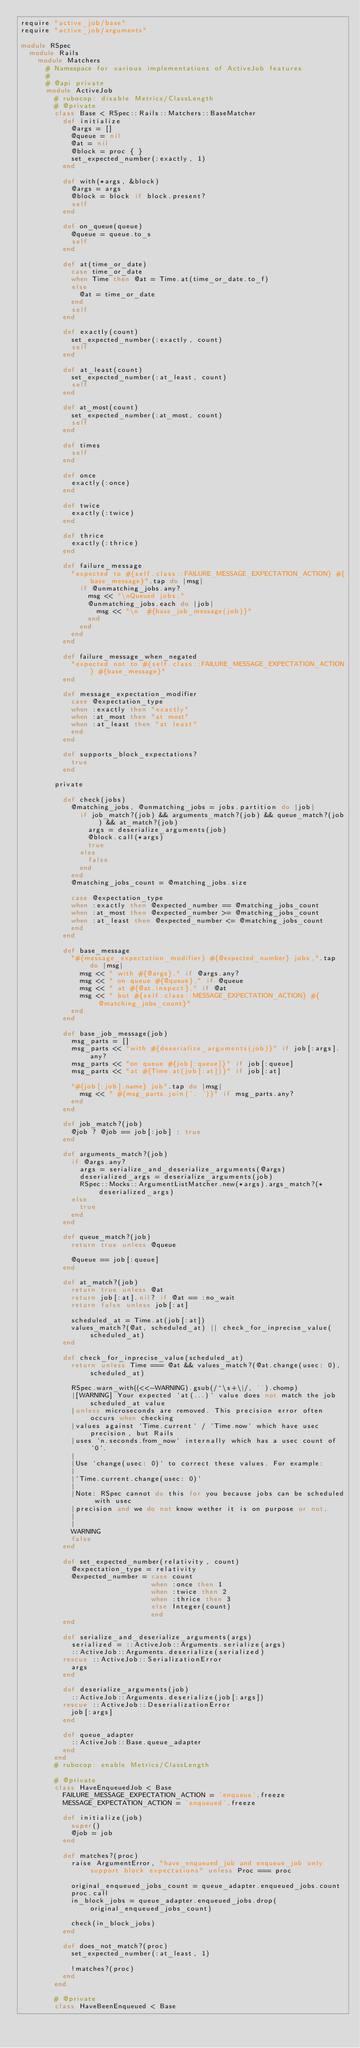Convert code to text. <code><loc_0><loc_0><loc_500><loc_500><_Ruby_>require "active_job/base"
require "active_job/arguments"

module RSpec
  module Rails
    module Matchers
      # Namespace for various implementations of ActiveJob features
      #
      # @api private
      module ActiveJob
        # rubocop: disable Metrics/ClassLength
        # @private
        class Base < RSpec::Rails::Matchers::BaseMatcher
          def initialize
            @args = []
            @queue = nil
            @at = nil
            @block = proc { }
            set_expected_number(:exactly, 1)
          end

          def with(*args, &block)
            @args = args
            @block = block if block.present?
            self
          end

          def on_queue(queue)
            @queue = queue.to_s
            self
          end

          def at(time_or_date)
            case time_or_date
            when Time then @at = Time.at(time_or_date.to_f)
            else
              @at = time_or_date
            end
            self
          end

          def exactly(count)
            set_expected_number(:exactly, count)
            self
          end

          def at_least(count)
            set_expected_number(:at_least, count)
            self
          end

          def at_most(count)
            set_expected_number(:at_most, count)
            self
          end

          def times
            self
          end

          def once
            exactly(:once)
          end

          def twice
            exactly(:twice)
          end

          def thrice
            exactly(:thrice)
          end

          def failure_message
            "expected to #{self.class::FAILURE_MESSAGE_EXPECTATION_ACTION} #{base_message}".tap do |msg|
              if @unmatching_jobs.any?
                msg << "\nQueued jobs:"
                @unmatching_jobs.each do |job|
                  msg << "\n  #{base_job_message(job)}"
                end
              end
            end
          end

          def failure_message_when_negated
            "expected not to #{self.class::FAILURE_MESSAGE_EXPECTATION_ACTION} #{base_message}"
          end

          def message_expectation_modifier
            case @expectation_type
            when :exactly then "exactly"
            when :at_most then "at most"
            when :at_least then "at least"
            end
          end

          def supports_block_expectations?
            true
          end

        private

          def check(jobs)
            @matching_jobs, @unmatching_jobs = jobs.partition do |job|
              if job_match?(job) && arguments_match?(job) && queue_match?(job) && at_match?(job)
                args = deserialize_arguments(job)
                @block.call(*args)
                true
              else
                false
              end
            end
            @matching_jobs_count = @matching_jobs.size

            case @expectation_type
            when :exactly then @expected_number == @matching_jobs_count
            when :at_most then @expected_number >= @matching_jobs_count
            when :at_least then @expected_number <= @matching_jobs_count
            end
          end

          def base_message
            "#{message_expectation_modifier} #{@expected_number} jobs,".tap do |msg|
              msg << " with #{@args}," if @args.any?
              msg << " on queue #{@queue}," if @queue
              msg << " at #{@at.inspect}," if @at
              msg << " but #{self.class::MESSAGE_EXPECTATION_ACTION} #{@matching_jobs_count}"
            end
          end

          def base_job_message(job)
            msg_parts = []
            msg_parts << "with #{deserialize_arguments(job)}" if job[:args].any?
            msg_parts << "on queue #{job[:queue]}" if job[:queue]
            msg_parts << "at #{Time.at(job[:at])}" if job[:at]

            "#{job[:job].name} job".tap do |msg|
              msg << " #{msg_parts.join(', ')}" if msg_parts.any?
            end
          end

          def job_match?(job)
            @job ? @job == job[:job] : true
          end

          def arguments_match?(job)
            if @args.any?
              args = serialize_and_deserialize_arguments(@args)
              deserialized_args = deserialize_arguments(job)
              RSpec::Mocks::ArgumentListMatcher.new(*args).args_match?(*deserialized_args)
            else
              true
            end
          end

          def queue_match?(job)
            return true unless @queue

            @queue == job[:queue]
          end

          def at_match?(job)
            return true unless @at
            return job[:at].nil? if @at == :no_wait
            return false unless job[:at]

            scheduled_at = Time.at(job[:at])
            values_match?(@at, scheduled_at) || check_for_inprecise_value(scheduled_at)
          end

          def check_for_inprecise_value(scheduled_at)
            return unless Time === @at && values_match?(@at.change(usec: 0), scheduled_at)

            RSpec.warn_with((<<-WARNING).gsub(/^\s+\|/, '').chomp)
            |[WARNING] Your expected `at(...)` value does not match the job scheduled_at value
            |unless microseconds are removed. This precision error often occurs when checking
            |values against `Time.current` / `Time.now` which have usec precision, but Rails
            |uses `n.seconds.from_now` internally which has a usec count of `0`.
            |
            |Use `change(usec: 0)` to correct these values. For example:
            |
            |`Time.current.change(usec: 0)`
            |
            |Note: RSpec cannot do this for you because jobs can be scheduled with usec
            |precision and we do not know wether it is on purpose or not.
            |
            |
            WARNING
            false
          end

          def set_expected_number(relativity, count)
            @expectation_type = relativity
            @expected_number = case count
                               when :once then 1
                               when :twice then 2
                               when :thrice then 3
                               else Integer(count)
                               end
          end

          def serialize_and_deserialize_arguments(args)
            serialized = ::ActiveJob::Arguments.serialize(args)
            ::ActiveJob::Arguments.deserialize(serialized)
          rescue ::ActiveJob::SerializationError
            args
          end

          def deserialize_arguments(job)
            ::ActiveJob::Arguments.deserialize(job[:args])
          rescue ::ActiveJob::DeserializationError
            job[:args]
          end

          def queue_adapter
            ::ActiveJob::Base.queue_adapter
          end
        end
        # rubocop: enable Metrics/ClassLength

        # @private
        class HaveEnqueuedJob < Base
          FAILURE_MESSAGE_EXPECTATION_ACTION = 'enqueue'.freeze
          MESSAGE_EXPECTATION_ACTION = 'enqueued'.freeze

          def initialize(job)
            super()
            @job = job
          end

          def matches?(proc)
            raise ArgumentError, "have_enqueued_job and enqueue_job only support block expectations" unless Proc === proc

            original_enqueued_jobs_count = queue_adapter.enqueued_jobs.count
            proc.call
            in_block_jobs = queue_adapter.enqueued_jobs.drop(original_enqueued_jobs_count)

            check(in_block_jobs)
          end

          def does_not_match?(proc)
            set_expected_number(:at_least, 1)

            !matches?(proc)
          end
        end

        # @private
        class HaveBeenEnqueued < Base</code> 